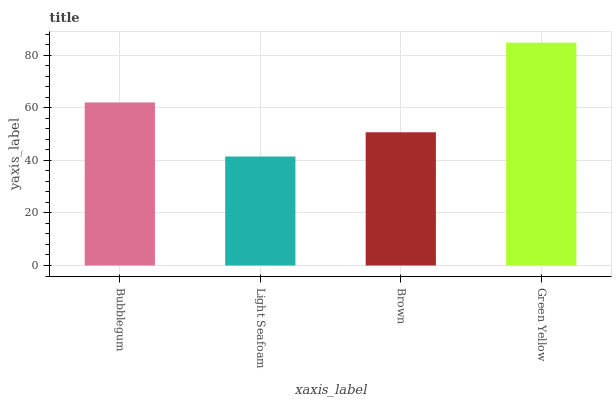Is Light Seafoam the minimum?
Answer yes or no. Yes. Is Green Yellow the maximum?
Answer yes or no. Yes. Is Brown the minimum?
Answer yes or no. No. Is Brown the maximum?
Answer yes or no. No. Is Brown greater than Light Seafoam?
Answer yes or no. Yes. Is Light Seafoam less than Brown?
Answer yes or no. Yes. Is Light Seafoam greater than Brown?
Answer yes or no. No. Is Brown less than Light Seafoam?
Answer yes or no. No. Is Bubblegum the high median?
Answer yes or no. Yes. Is Brown the low median?
Answer yes or no. Yes. Is Light Seafoam the high median?
Answer yes or no. No. Is Green Yellow the low median?
Answer yes or no. No. 